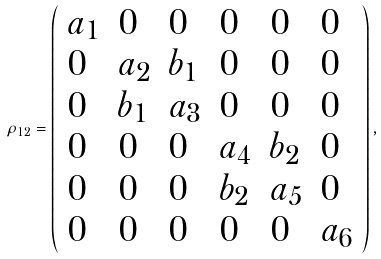<formula> <loc_0><loc_0><loc_500><loc_500>\rho _ { 1 2 } = \left ( \begin{array} { l l l l l l } a _ { 1 } & 0 & 0 & 0 & 0 & 0 \\ 0 & a _ { 2 } & b _ { 1 } & 0 & 0 & 0 \\ 0 & b _ { 1 } & a _ { 3 } & 0 & 0 & 0 \\ 0 & 0 & 0 & a _ { 4 } & b _ { 2 } & 0 \\ 0 & 0 & 0 & b _ { 2 } & a _ { 5 } & 0 \\ 0 & 0 & 0 & 0 & 0 & a _ { 6 } \end{array} \right ) ,</formula> 